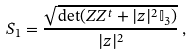<formula> <loc_0><loc_0><loc_500><loc_500>S _ { 1 } = \frac { \sqrt { \det ( Z Z ^ { t } + | z | ^ { 2 } \mathbb { I } _ { 3 } ) } } { | z | ^ { 2 } } \, ,</formula> 